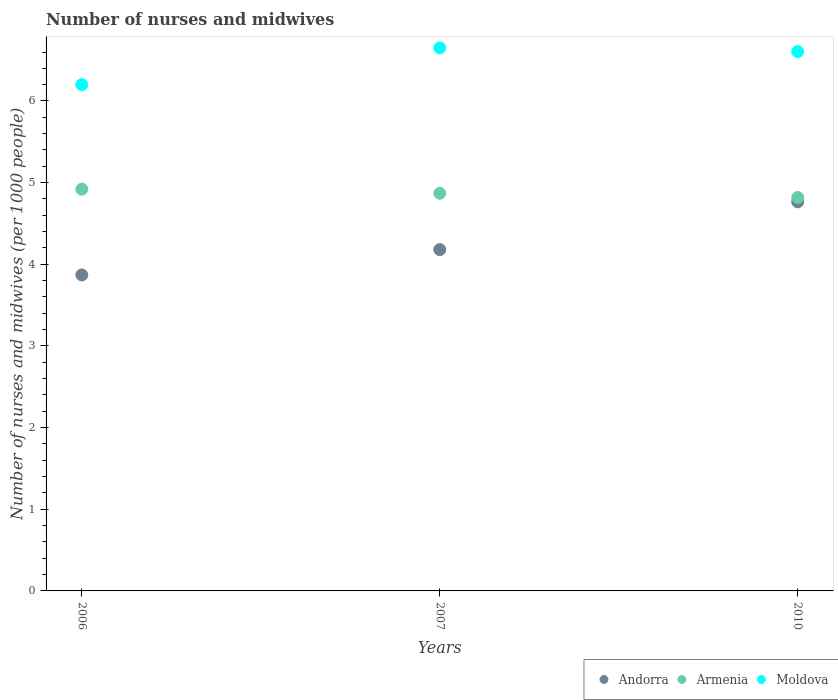Is the number of dotlines equal to the number of legend labels?
Ensure brevity in your answer.  Yes. What is the number of nurses and midwives in in Armenia in 2007?
Offer a very short reply. 4.87. Across all years, what is the maximum number of nurses and midwives in in Armenia?
Offer a terse response. 4.92. Across all years, what is the minimum number of nurses and midwives in in Andorra?
Your answer should be very brief. 3.87. In which year was the number of nurses and midwives in in Armenia minimum?
Ensure brevity in your answer.  2010. What is the total number of nurses and midwives in in Moldova in the graph?
Offer a very short reply. 19.46. What is the difference between the number of nurses and midwives in in Andorra in 2006 and that in 2010?
Keep it short and to the point. -0.89. What is the difference between the number of nurses and midwives in in Moldova in 2006 and the number of nurses and midwives in in Armenia in 2010?
Offer a very short reply. 1.38. What is the average number of nurses and midwives in in Armenia per year?
Keep it short and to the point. 4.87. In the year 2010, what is the difference between the number of nurses and midwives in in Armenia and number of nurses and midwives in in Andorra?
Make the answer very short. 0.05. What is the ratio of the number of nurses and midwives in in Andorra in 2006 to that in 2010?
Offer a very short reply. 0.81. Is the number of nurses and midwives in in Moldova in 2007 less than that in 2010?
Offer a very short reply. No. What is the difference between the highest and the second highest number of nurses and midwives in in Armenia?
Your answer should be compact. 0.05. What is the difference between the highest and the lowest number of nurses and midwives in in Moldova?
Make the answer very short. 0.45. In how many years, is the number of nurses and midwives in in Andorra greater than the average number of nurses and midwives in in Andorra taken over all years?
Provide a succinct answer. 1. Does the number of nurses and midwives in in Moldova monotonically increase over the years?
Your answer should be very brief. No. Is the number of nurses and midwives in in Moldova strictly greater than the number of nurses and midwives in in Armenia over the years?
Keep it short and to the point. Yes. How many years are there in the graph?
Ensure brevity in your answer.  3. Are the values on the major ticks of Y-axis written in scientific E-notation?
Ensure brevity in your answer.  No. Does the graph contain any zero values?
Provide a succinct answer. No. Does the graph contain grids?
Offer a very short reply. No. How many legend labels are there?
Offer a very short reply. 3. How are the legend labels stacked?
Give a very brief answer. Horizontal. What is the title of the graph?
Make the answer very short. Number of nurses and midwives. Does "Indonesia" appear as one of the legend labels in the graph?
Your answer should be very brief. No. What is the label or title of the Y-axis?
Your response must be concise. Number of nurses and midwives (per 1000 people). What is the Number of nurses and midwives (per 1000 people) in Andorra in 2006?
Offer a very short reply. 3.87. What is the Number of nurses and midwives (per 1000 people) in Armenia in 2006?
Your response must be concise. 4.92. What is the Number of nurses and midwives (per 1000 people) in Andorra in 2007?
Provide a succinct answer. 4.18. What is the Number of nurses and midwives (per 1000 people) of Armenia in 2007?
Your response must be concise. 4.87. What is the Number of nurses and midwives (per 1000 people) of Moldova in 2007?
Make the answer very short. 6.65. What is the Number of nurses and midwives (per 1000 people) in Andorra in 2010?
Offer a very short reply. 4.76. What is the Number of nurses and midwives (per 1000 people) of Armenia in 2010?
Give a very brief answer. 4.82. What is the Number of nurses and midwives (per 1000 people) of Moldova in 2010?
Provide a short and direct response. 6.61. Across all years, what is the maximum Number of nurses and midwives (per 1000 people) in Andorra?
Offer a terse response. 4.76. Across all years, what is the maximum Number of nurses and midwives (per 1000 people) of Armenia?
Make the answer very short. 4.92. Across all years, what is the maximum Number of nurses and midwives (per 1000 people) of Moldova?
Provide a succinct answer. 6.65. Across all years, what is the minimum Number of nurses and midwives (per 1000 people) in Andorra?
Give a very brief answer. 3.87. Across all years, what is the minimum Number of nurses and midwives (per 1000 people) in Armenia?
Make the answer very short. 4.82. What is the total Number of nurses and midwives (per 1000 people) in Andorra in the graph?
Keep it short and to the point. 12.81. What is the total Number of nurses and midwives (per 1000 people) in Armenia in the graph?
Your answer should be very brief. 14.61. What is the total Number of nurses and midwives (per 1000 people) of Moldova in the graph?
Give a very brief answer. 19.45. What is the difference between the Number of nurses and midwives (per 1000 people) in Andorra in 2006 and that in 2007?
Give a very brief answer. -0.31. What is the difference between the Number of nurses and midwives (per 1000 people) in Moldova in 2006 and that in 2007?
Ensure brevity in your answer.  -0.45. What is the difference between the Number of nurses and midwives (per 1000 people) in Andorra in 2006 and that in 2010?
Ensure brevity in your answer.  -0.9. What is the difference between the Number of nurses and midwives (per 1000 people) in Armenia in 2006 and that in 2010?
Provide a succinct answer. 0.1. What is the difference between the Number of nurses and midwives (per 1000 people) of Moldova in 2006 and that in 2010?
Your response must be concise. -0.41. What is the difference between the Number of nurses and midwives (per 1000 people) of Andorra in 2007 and that in 2010?
Offer a terse response. -0.58. What is the difference between the Number of nurses and midwives (per 1000 people) of Armenia in 2007 and that in 2010?
Keep it short and to the point. 0.05. What is the difference between the Number of nurses and midwives (per 1000 people) in Moldova in 2007 and that in 2010?
Provide a short and direct response. 0.04. What is the difference between the Number of nurses and midwives (per 1000 people) in Andorra in 2006 and the Number of nurses and midwives (per 1000 people) in Armenia in 2007?
Your response must be concise. -1. What is the difference between the Number of nurses and midwives (per 1000 people) in Andorra in 2006 and the Number of nurses and midwives (per 1000 people) in Moldova in 2007?
Keep it short and to the point. -2.78. What is the difference between the Number of nurses and midwives (per 1000 people) of Armenia in 2006 and the Number of nurses and midwives (per 1000 people) of Moldova in 2007?
Ensure brevity in your answer.  -1.73. What is the difference between the Number of nurses and midwives (per 1000 people) in Andorra in 2006 and the Number of nurses and midwives (per 1000 people) in Armenia in 2010?
Provide a short and direct response. -0.95. What is the difference between the Number of nurses and midwives (per 1000 people) in Andorra in 2006 and the Number of nurses and midwives (per 1000 people) in Moldova in 2010?
Your response must be concise. -2.73. What is the difference between the Number of nurses and midwives (per 1000 people) in Armenia in 2006 and the Number of nurses and midwives (per 1000 people) in Moldova in 2010?
Offer a very short reply. -1.69. What is the difference between the Number of nurses and midwives (per 1000 people) in Andorra in 2007 and the Number of nurses and midwives (per 1000 people) in Armenia in 2010?
Make the answer very short. -0.64. What is the difference between the Number of nurses and midwives (per 1000 people) of Andorra in 2007 and the Number of nurses and midwives (per 1000 people) of Moldova in 2010?
Provide a succinct answer. -2.42. What is the difference between the Number of nurses and midwives (per 1000 people) of Armenia in 2007 and the Number of nurses and midwives (per 1000 people) of Moldova in 2010?
Provide a short and direct response. -1.74. What is the average Number of nurses and midwives (per 1000 people) of Andorra per year?
Make the answer very short. 4.27. What is the average Number of nurses and midwives (per 1000 people) of Armenia per year?
Ensure brevity in your answer.  4.87. What is the average Number of nurses and midwives (per 1000 people) in Moldova per year?
Provide a short and direct response. 6.49. In the year 2006, what is the difference between the Number of nurses and midwives (per 1000 people) in Andorra and Number of nurses and midwives (per 1000 people) in Armenia?
Ensure brevity in your answer.  -1.05. In the year 2006, what is the difference between the Number of nurses and midwives (per 1000 people) in Andorra and Number of nurses and midwives (per 1000 people) in Moldova?
Provide a succinct answer. -2.33. In the year 2006, what is the difference between the Number of nurses and midwives (per 1000 people) in Armenia and Number of nurses and midwives (per 1000 people) in Moldova?
Offer a very short reply. -1.28. In the year 2007, what is the difference between the Number of nurses and midwives (per 1000 people) of Andorra and Number of nurses and midwives (per 1000 people) of Armenia?
Ensure brevity in your answer.  -0.69. In the year 2007, what is the difference between the Number of nurses and midwives (per 1000 people) of Andorra and Number of nurses and midwives (per 1000 people) of Moldova?
Provide a succinct answer. -2.47. In the year 2007, what is the difference between the Number of nurses and midwives (per 1000 people) of Armenia and Number of nurses and midwives (per 1000 people) of Moldova?
Your response must be concise. -1.78. In the year 2010, what is the difference between the Number of nurses and midwives (per 1000 people) of Andorra and Number of nurses and midwives (per 1000 people) of Armenia?
Make the answer very short. -0.05. In the year 2010, what is the difference between the Number of nurses and midwives (per 1000 people) of Andorra and Number of nurses and midwives (per 1000 people) of Moldova?
Your answer should be compact. -1.84. In the year 2010, what is the difference between the Number of nurses and midwives (per 1000 people) in Armenia and Number of nurses and midwives (per 1000 people) in Moldova?
Your response must be concise. -1.79. What is the ratio of the Number of nurses and midwives (per 1000 people) of Andorra in 2006 to that in 2007?
Your answer should be very brief. 0.93. What is the ratio of the Number of nurses and midwives (per 1000 people) of Armenia in 2006 to that in 2007?
Offer a very short reply. 1.01. What is the ratio of the Number of nurses and midwives (per 1000 people) of Moldova in 2006 to that in 2007?
Your answer should be compact. 0.93. What is the ratio of the Number of nurses and midwives (per 1000 people) in Andorra in 2006 to that in 2010?
Ensure brevity in your answer.  0.81. What is the ratio of the Number of nurses and midwives (per 1000 people) in Armenia in 2006 to that in 2010?
Your answer should be compact. 1.02. What is the ratio of the Number of nurses and midwives (per 1000 people) of Moldova in 2006 to that in 2010?
Offer a very short reply. 0.94. What is the ratio of the Number of nurses and midwives (per 1000 people) in Andorra in 2007 to that in 2010?
Your answer should be compact. 0.88. What is the ratio of the Number of nurses and midwives (per 1000 people) of Armenia in 2007 to that in 2010?
Ensure brevity in your answer.  1.01. What is the ratio of the Number of nurses and midwives (per 1000 people) of Moldova in 2007 to that in 2010?
Give a very brief answer. 1.01. What is the difference between the highest and the second highest Number of nurses and midwives (per 1000 people) of Andorra?
Make the answer very short. 0.58. What is the difference between the highest and the second highest Number of nurses and midwives (per 1000 people) of Armenia?
Your answer should be very brief. 0.05. What is the difference between the highest and the second highest Number of nurses and midwives (per 1000 people) of Moldova?
Ensure brevity in your answer.  0.04. What is the difference between the highest and the lowest Number of nurses and midwives (per 1000 people) in Andorra?
Your answer should be compact. 0.9. What is the difference between the highest and the lowest Number of nurses and midwives (per 1000 people) of Armenia?
Your answer should be compact. 0.1. What is the difference between the highest and the lowest Number of nurses and midwives (per 1000 people) of Moldova?
Provide a short and direct response. 0.45. 